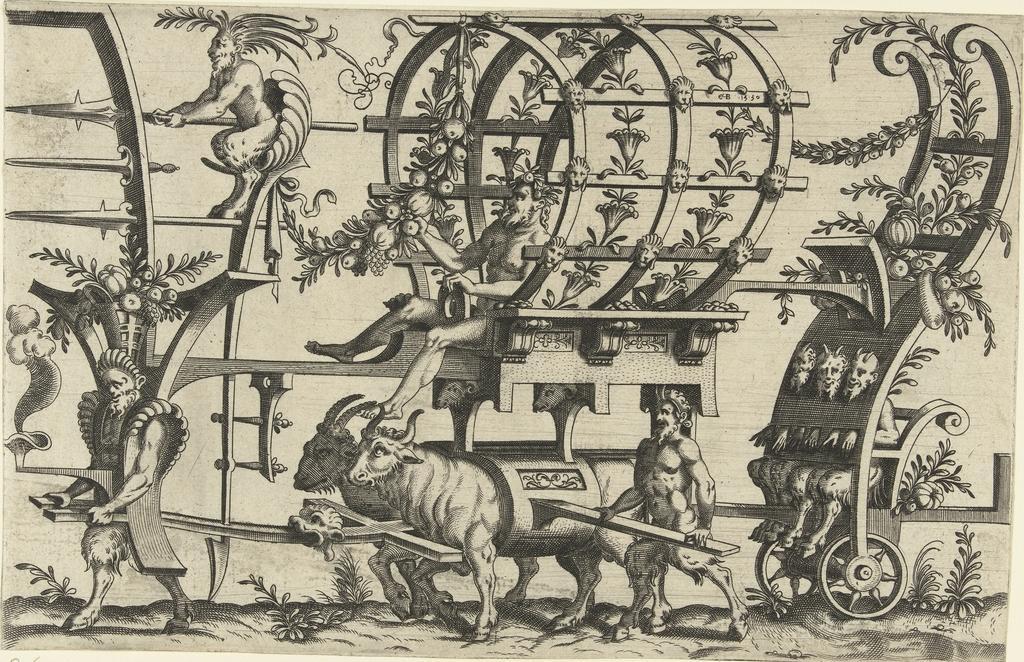Can you describe this image briefly? This picture consists of a poster, where we can see animals, creepers, and centaurs. 